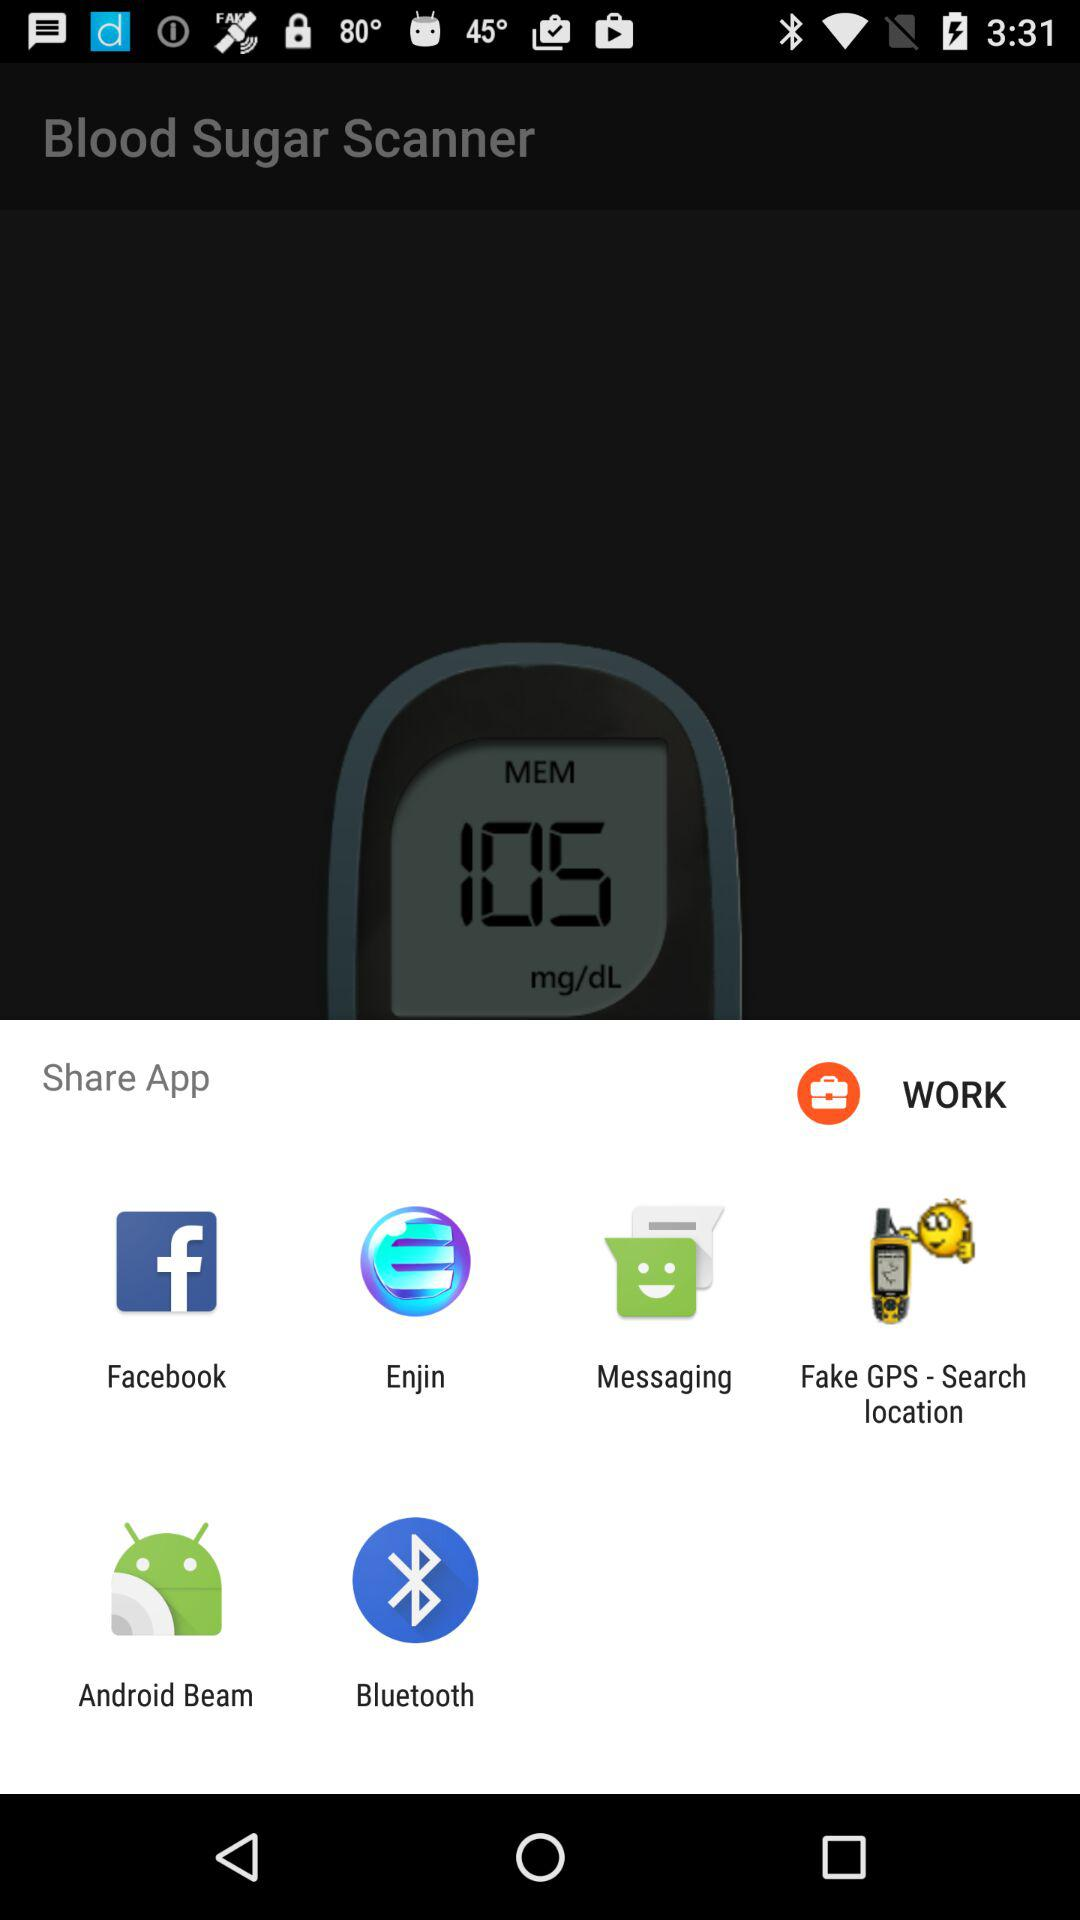When was the blood sugar last scanned?
When the provided information is insufficient, respond with <no answer>. <no answer> 